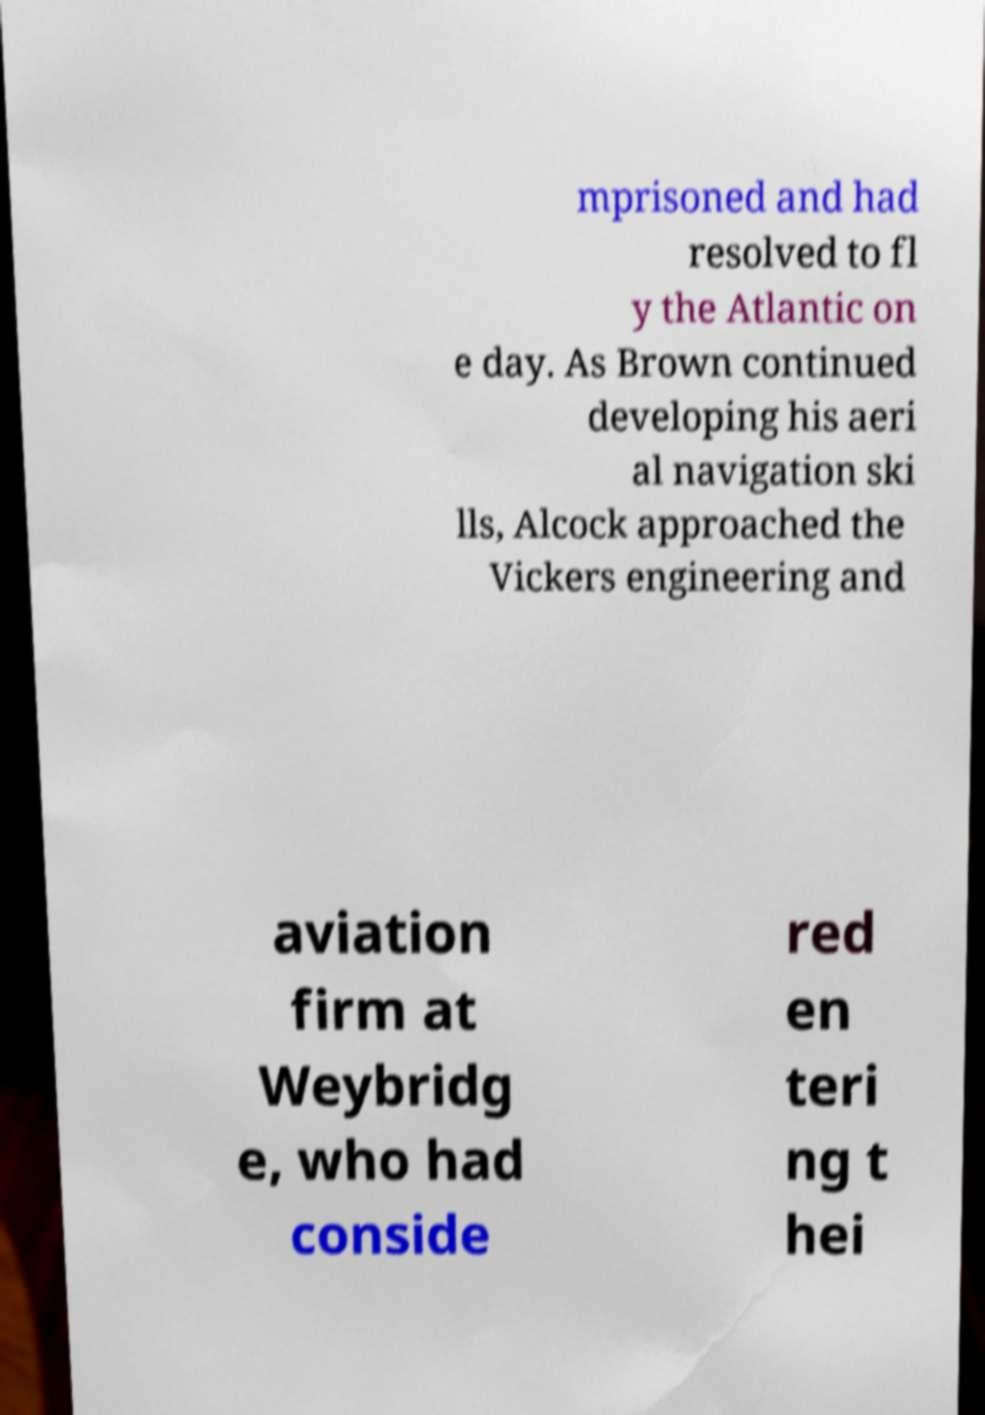Could you extract and type out the text from this image? mprisoned and had resolved to fl y the Atlantic on e day. As Brown continued developing his aeri al navigation ski lls, Alcock approached the Vickers engineering and aviation firm at Weybridg e, who had conside red en teri ng t hei 